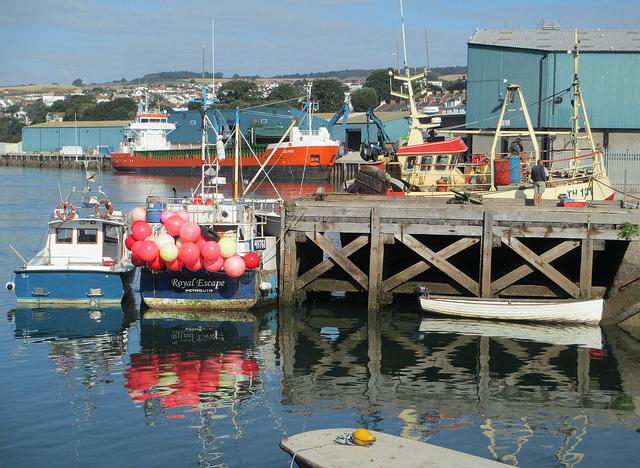Why are all those balloons in the boat? Please explain your reasoning. celebration. The balloons are for a festive event. 